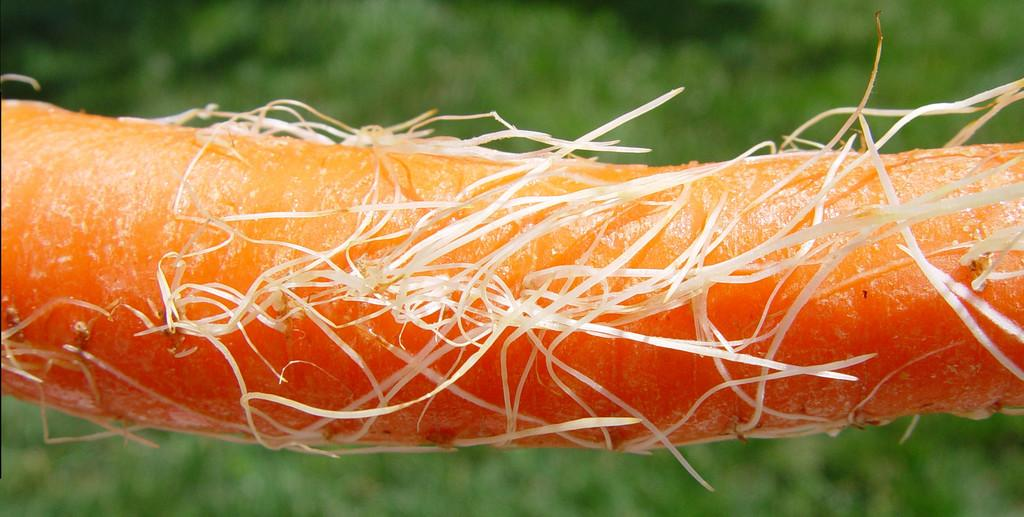What type of vegetable is present in the image? There is an orange color carrot in the image. Can you describe the background of the image? The background of the image is blurred. What does the carrot smell like in the image? The image does not provide any information about the smell of the carrot, so it cannot be determined from the image. 